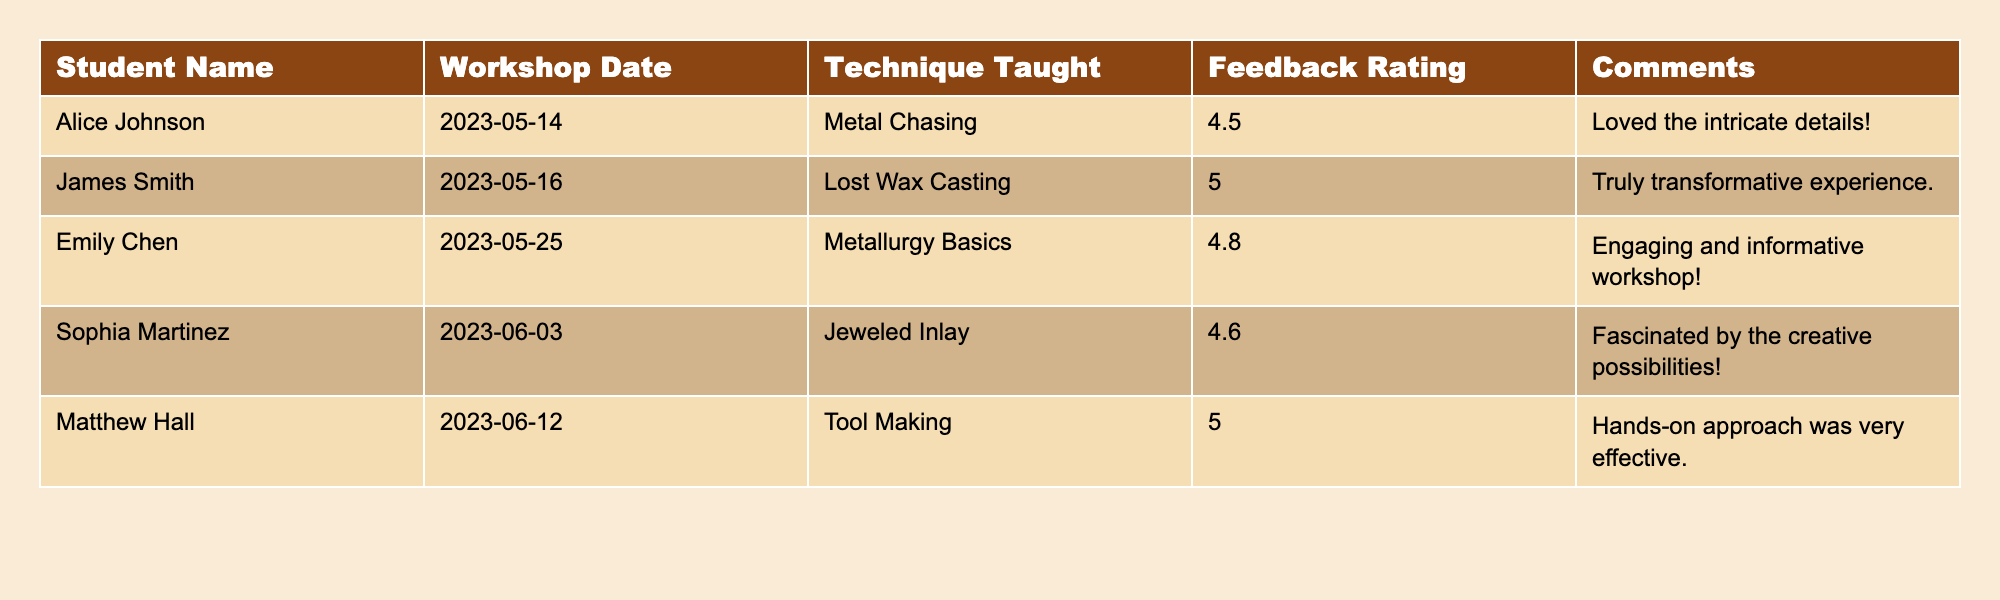What technique received the highest feedback rating? The table shows that the highest feedback rating is 5.0, which corresponds to the techniques "Lost Wax Casting" and "Tool Making," taught by James Smith and Matthew Hall respectively.
Answer: Tool Making and Lost Wax Casting What is the average feedback rating of all workshops? To find the average, sum the feedback ratings (4.5 + 5.0 + 4.8 + 4.6 + 5.0) which equals 24. The number of workshops is 5, so the average is 24/5 = 4.8.
Answer: 4.8 Did any student give a feedback rating of 4.0 or below? Upon reviewing the feedback ratings in the table, all ratings are above 4.0, indicating that no student rated their experience at or below that value.
Answer: No Which student provided the comment "Loved the intricate details!"? The comment "Loved the intricate details!" is associated with the student Alice Johnson, who attended the workshop on "Metal Chasing."
Answer: Alice Johnson What is the difference in feedback ratings between the workshop on Lost Wax Casting and the workshop on Metal Chasing? The feedback rating for Lost Wax Casting is 5.0, and for Metal Chasing, it is 4.5. The difference is calculated as 5.0 - 4.5 = 0.5.
Answer: 0.5 Who had the most positive feedback comment, and what was it? James Smith provided the comment "Truly transformative experience." with a feedback rating of 5.0, highlighting the most positive feedback among the students.
Answer: James Smith, "Truly transformative experience." 